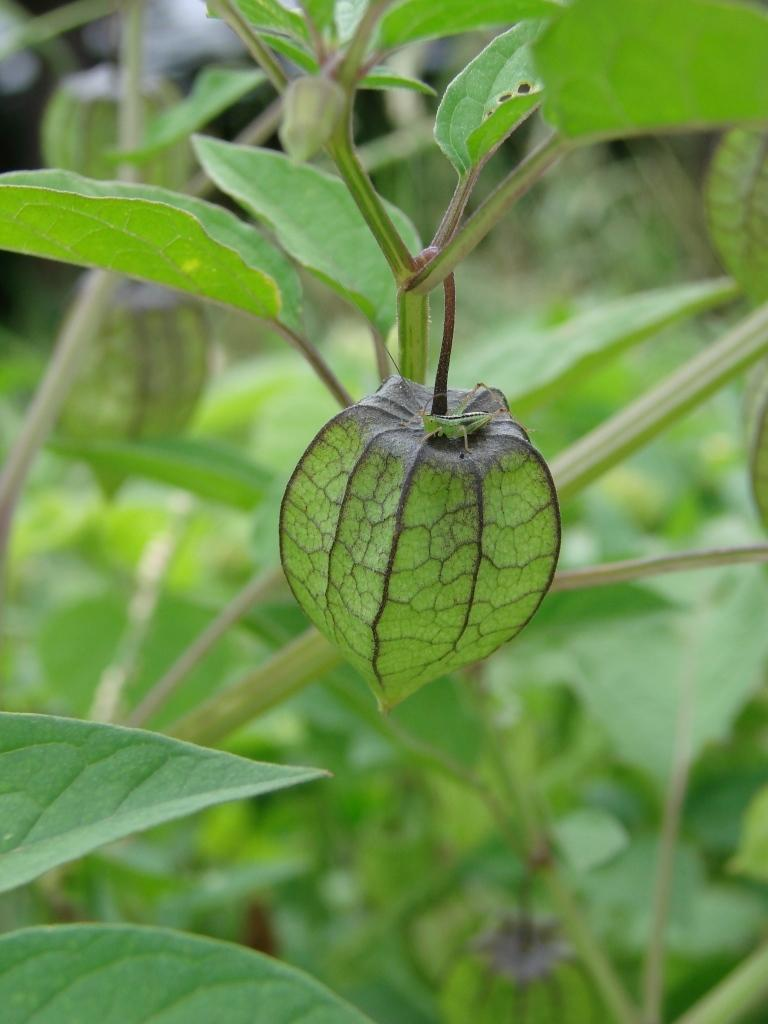What stage of growth are the plants in the image? The plants in the image have buds, indicating that they are in an early stage of growth. Can you describe any living organisms present on the plants? Yes, there is a green color insect on one of the buds. What can be observed about the background of the image? The background of the image is blurred. What type of steel is being processed in the image? There is no steel or any indication of a processing activity in the image; it features plants with buds and an insect. 